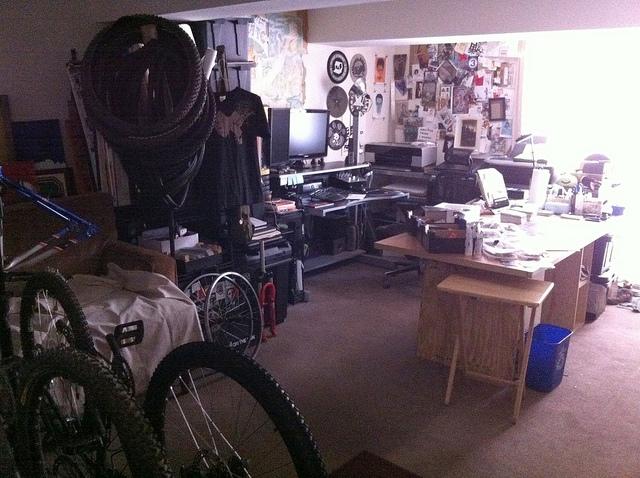Does the person who lives here like Bicycles?
Quick response, please. Yes. Is that folding table made out of wood?
Write a very short answer. Yes. How many people live here?
Short answer required. 3. 